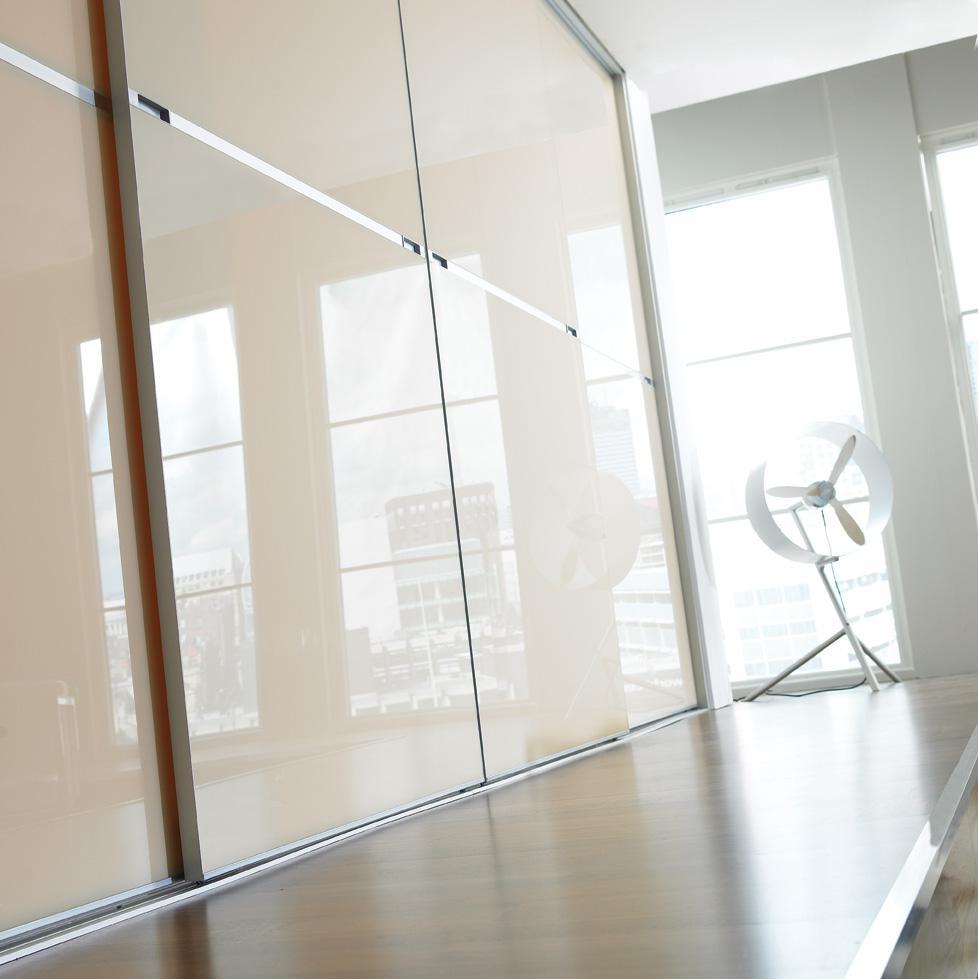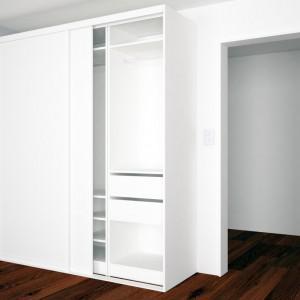The first image is the image on the left, the second image is the image on the right. Considering the images on both sides, is "There is a chair in the image on the right." valid? Answer yes or no. No. 